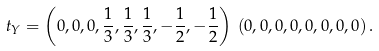Convert formula to latex. <formula><loc_0><loc_0><loc_500><loc_500>t _ { Y } = \left ( 0 , 0 , 0 , \frac { 1 } { 3 } , \frac { 1 } { 3 } , \frac { 1 } { 3 } , - \frac { 1 } { 2 } , - \frac { 1 } { 2 } \right ) \, ( 0 , 0 , 0 , 0 , 0 , 0 , 0 , 0 ) \, .</formula> 